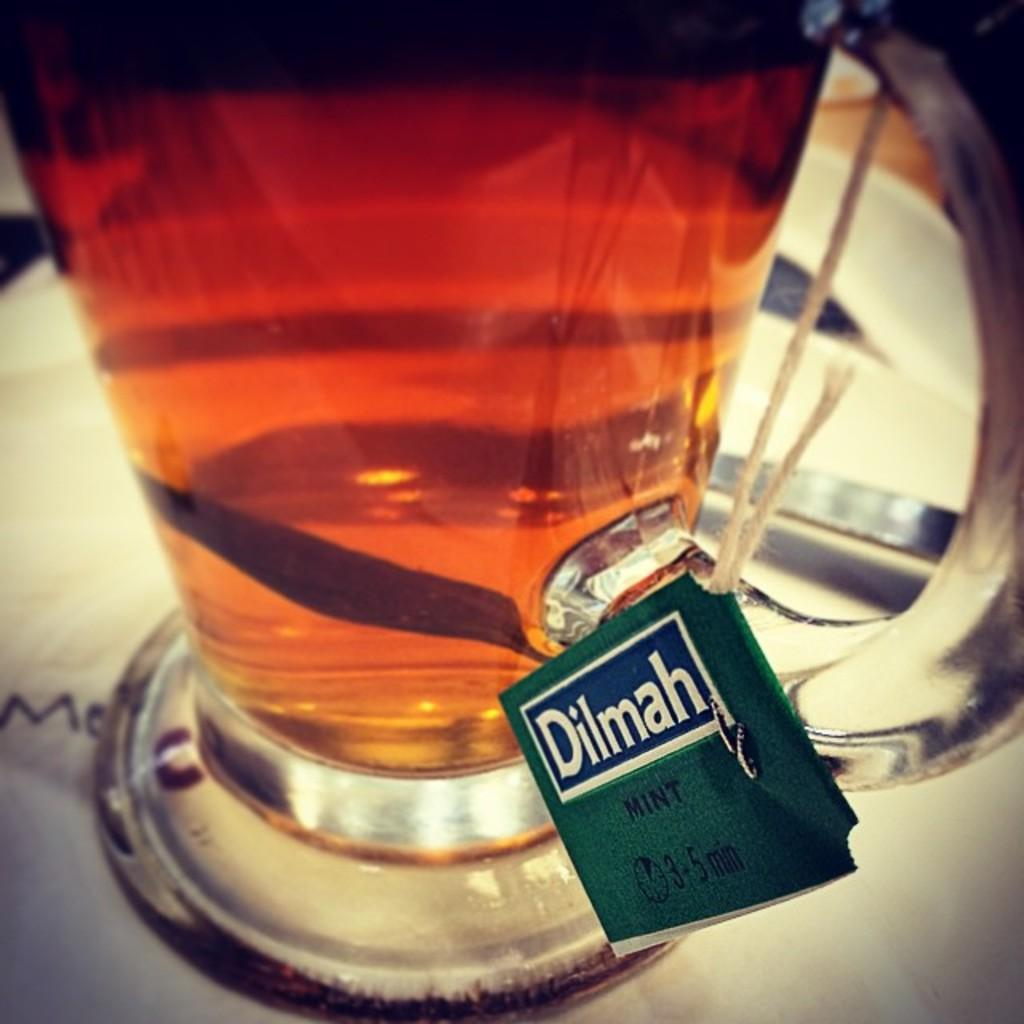<image>
Relay a brief, clear account of the picture shown. A clear mug filled with Dilmah Mint tea 